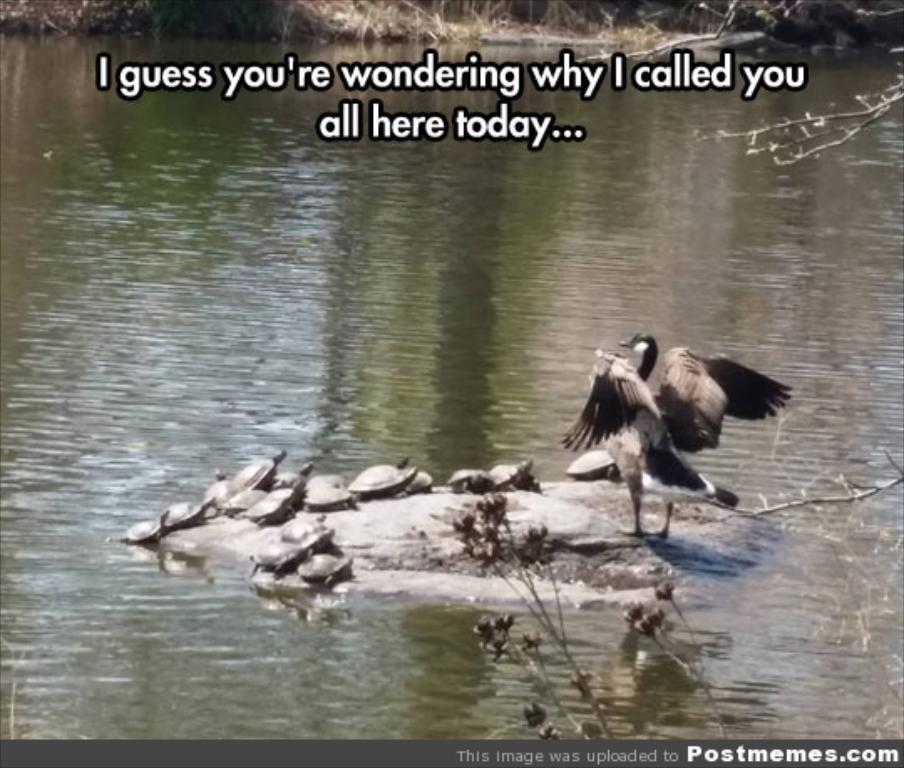What body of water is present in the image? There is a lake in the image. What type of animals can be seen in the lake? There are tortoises in the lake. Can you describe the bird in the image? There is a bird on a rock in the image. What type of vegetation is visible in the image? There are plants visible in the image. What type of cent is present in the image? There is no cent present in the image. Where is the meeting taking place in the image? There is no meeting depicted in the image. 